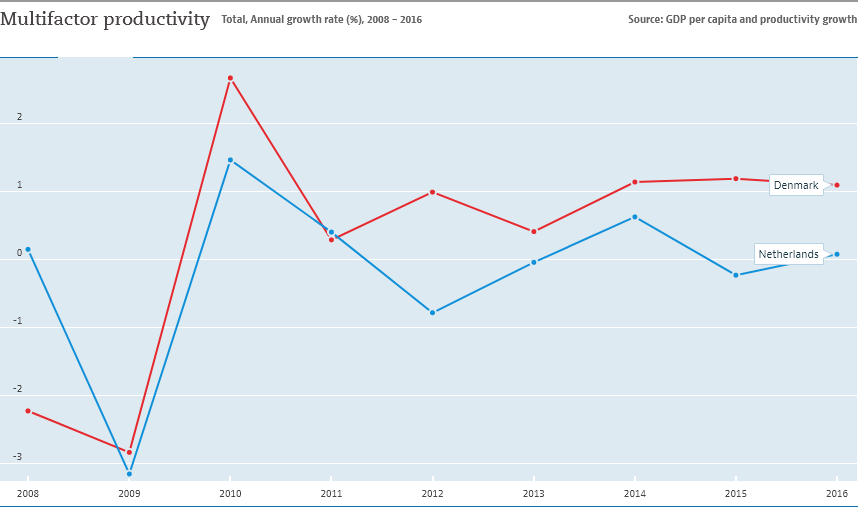List a handful of essential elements in this visual. In 2011, the value of multifactor productivity was closer among the two countries. The Netherlands achieved the lowest value of multifactor productivity in 2009. 